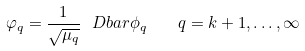Convert formula to latex. <formula><loc_0><loc_0><loc_500><loc_500>\varphi _ { q } = \frac { 1 } { \sqrt { \mu _ { q } } } \ D b a r \phi _ { q } \quad q = k + 1 , \dots , \infty</formula> 